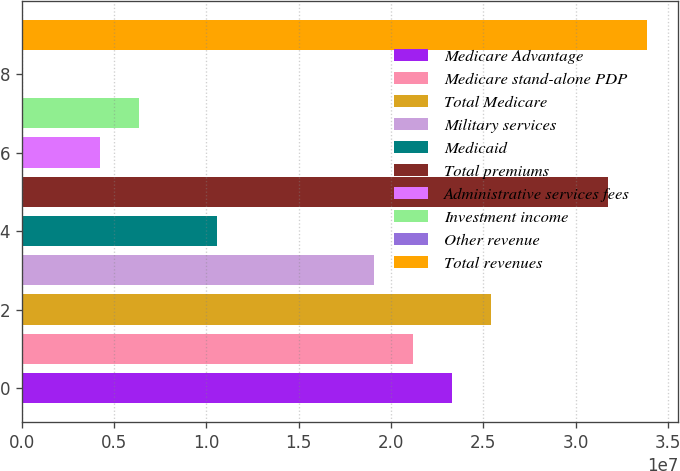<chart> <loc_0><loc_0><loc_500><loc_500><bar_chart><fcel>Medicare Advantage<fcel>Medicare stand-alone PDP<fcel>Total Medicare<fcel>Military services<fcel>Medicaid<fcel>Total premiums<fcel>Administrative services fees<fcel>Investment income<fcel>Other revenue<fcel>Total revenues<nl><fcel>2.32879e+07<fcel>2.1171e+07<fcel>2.54049e+07<fcel>1.90541e+07<fcel>1.05864e+07<fcel>3.17556e+07<fcel>4.23563e+06<fcel>6.35255e+06<fcel>1782<fcel>3.38726e+07<nl></chart> 